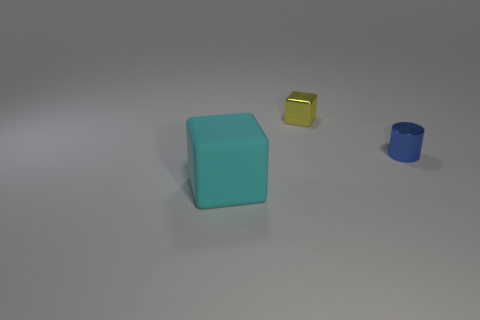Add 3 blue matte cubes. How many objects exist? 6 Subtract all blocks. How many objects are left? 1 Subtract 0 green balls. How many objects are left? 3 Subtract all gray matte spheres. Subtract all cyan things. How many objects are left? 2 Add 2 small blue things. How many small blue things are left? 3 Add 3 tiny purple cylinders. How many tiny purple cylinders exist? 3 